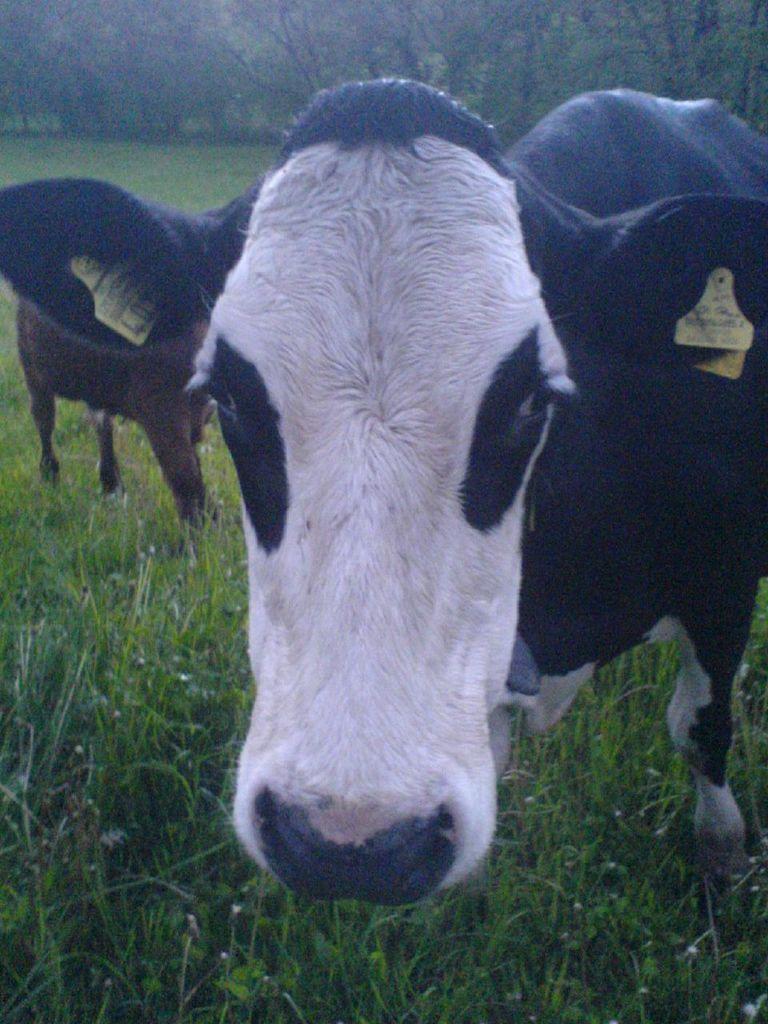Please provide a concise description of this image. In this picture I can see the grass at the bottom, in the middle there are animals. In the background there are trees. 